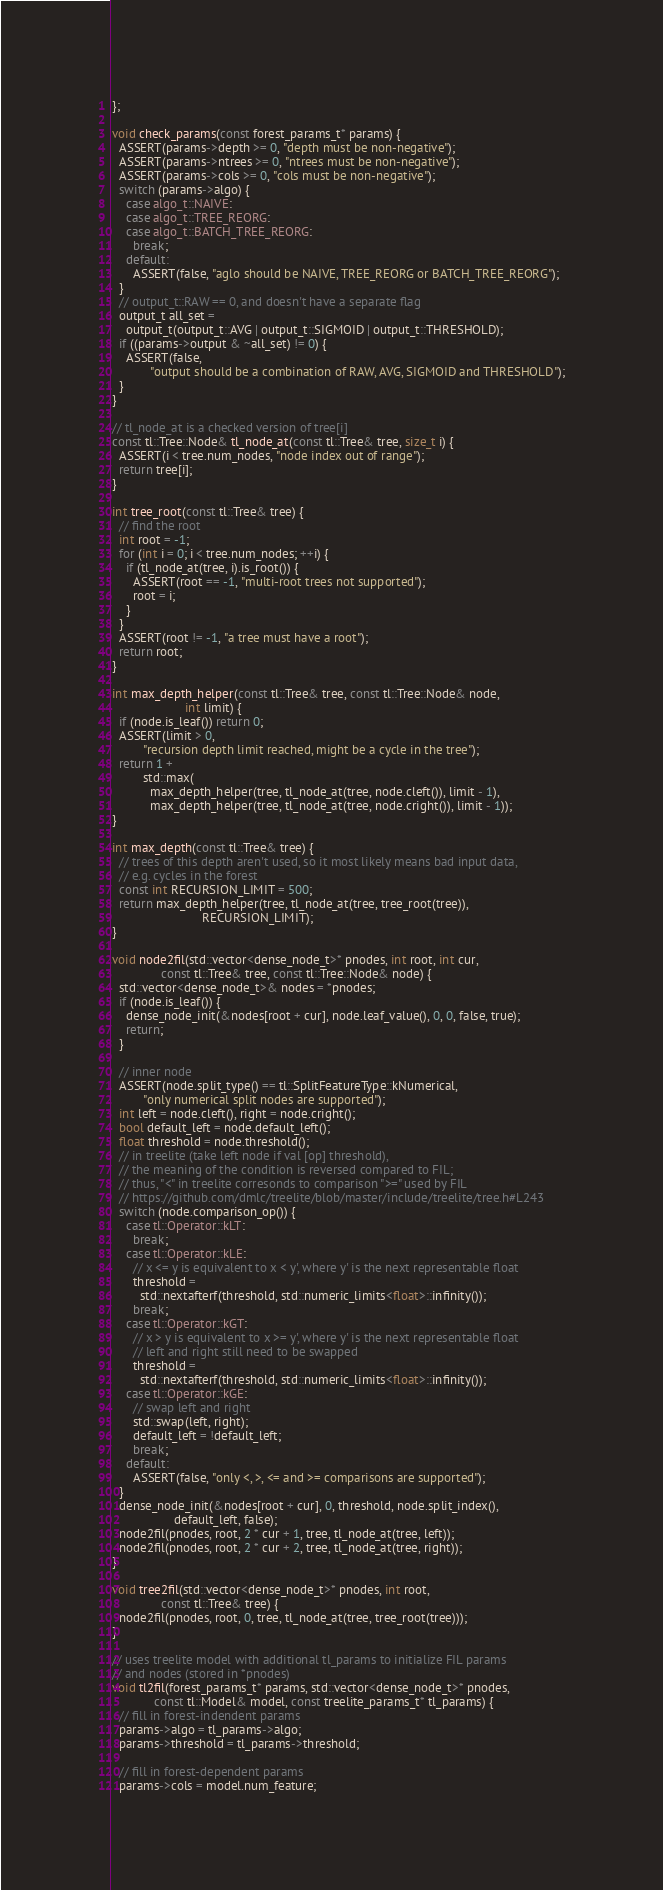Convert code to text. <code><loc_0><loc_0><loc_500><loc_500><_Cuda_>};

void check_params(const forest_params_t* params) {
  ASSERT(params->depth >= 0, "depth must be non-negative");
  ASSERT(params->ntrees >= 0, "ntrees must be non-negative");
  ASSERT(params->cols >= 0, "cols must be non-negative");
  switch (params->algo) {
    case algo_t::NAIVE:
    case algo_t::TREE_REORG:
    case algo_t::BATCH_TREE_REORG:
      break;
    default:
      ASSERT(false, "aglo should be NAIVE, TREE_REORG or BATCH_TREE_REORG");
  }
  // output_t::RAW == 0, and doesn't have a separate flag
  output_t all_set =
    output_t(output_t::AVG | output_t::SIGMOID | output_t::THRESHOLD);
  if ((params->output & ~all_set) != 0) {
    ASSERT(false,
           "output should be a combination of RAW, AVG, SIGMOID and THRESHOLD");
  }
}

// tl_node_at is a checked version of tree[i]
const tl::Tree::Node& tl_node_at(const tl::Tree& tree, size_t i) {
  ASSERT(i < tree.num_nodes, "node index out of range");
  return tree[i];
}

int tree_root(const tl::Tree& tree) {
  // find the root
  int root = -1;
  for (int i = 0; i < tree.num_nodes; ++i) {
    if (tl_node_at(tree, i).is_root()) {
      ASSERT(root == -1, "multi-root trees not supported");
      root = i;
    }
  }
  ASSERT(root != -1, "a tree must have a root");
  return root;
}

int max_depth_helper(const tl::Tree& tree, const tl::Tree::Node& node,
                     int limit) {
  if (node.is_leaf()) return 0;
  ASSERT(limit > 0,
         "recursion depth limit reached, might be a cycle in the tree");
  return 1 +
         std::max(
           max_depth_helper(tree, tl_node_at(tree, node.cleft()), limit - 1),
           max_depth_helper(tree, tl_node_at(tree, node.cright()), limit - 1));
}

int max_depth(const tl::Tree& tree) {
  // trees of this depth aren't used, so it most likely means bad input data,
  // e.g. cycles in the forest
  const int RECURSION_LIMIT = 500;
  return max_depth_helper(tree, tl_node_at(tree, tree_root(tree)),
                          RECURSION_LIMIT);
}

void node2fil(std::vector<dense_node_t>* pnodes, int root, int cur,
              const tl::Tree& tree, const tl::Tree::Node& node) {
  std::vector<dense_node_t>& nodes = *pnodes;
  if (node.is_leaf()) {
    dense_node_init(&nodes[root + cur], node.leaf_value(), 0, 0, false, true);
    return;
  }

  // inner node
  ASSERT(node.split_type() == tl::SplitFeatureType::kNumerical,
         "only numerical split nodes are supported");
  int left = node.cleft(), right = node.cright();
  bool default_left = node.default_left();
  float threshold = node.threshold();
  // in treelite (take left node if val [op] threshold),
  // the meaning of the condition is reversed compared to FIL;
  // thus, "<" in treelite corresonds to comparison ">=" used by FIL
  // https://github.com/dmlc/treelite/blob/master/include/treelite/tree.h#L243
  switch (node.comparison_op()) {
    case tl::Operator::kLT:
      break;
    case tl::Operator::kLE:
      // x <= y is equivalent to x < y', where y' is the next representable float
      threshold =
        std::nextafterf(threshold, std::numeric_limits<float>::infinity());
      break;
    case tl::Operator::kGT:
      // x > y is equivalent to x >= y', where y' is the next representable float
      // left and right still need to be swapped
      threshold =
        std::nextafterf(threshold, std::numeric_limits<float>::infinity());
    case tl::Operator::kGE:
      // swap left and right
      std::swap(left, right);
      default_left = !default_left;
      break;
    default:
      ASSERT(false, "only <, >, <= and >= comparisons are supported");
  }
  dense_node_init(&nodes[root + cur], 0, threshold, node.split_index(),
                  default_left, false);
  node2fil(pnodes, root, 2 * cur + 1, tree, tl_node_at(tree, left));
  node2fil(pnodes, root, 2 * cur + 2, tree, tl_node_at(tree, right));
}

void tree2fil(std::vector<dense_node_t>* pnodes, int root,
              const tl::Tree& tree) {
  node2fil(pnodes, root, 0, tree, tl_node_at(tree, tree_root(tree)));
}

// uses treelite model with additional tl_params to initialize FIL params
// and nodes (stored in *pnodes)
void tl2fil(forest_params_t* params, std::vector<dense_node_t>* pnodes,
            const tl::Model& model, const treelite_params_t* tl_params) {
  // fill in forest-indendent params
  params->algo = tl_params->algo;
  params->threshold = tl_params->threshold;

  // fill in forest-dependent params
  params->cols = model.num_feature;</code> 